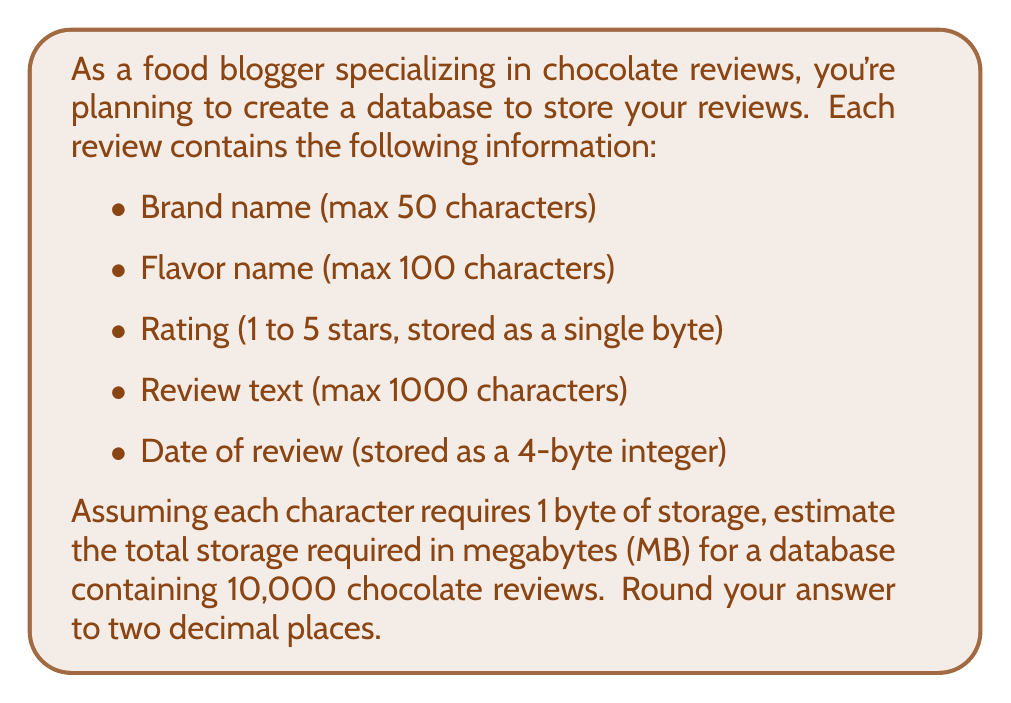Can you solve this math problem? Let's break down the storage requirements for each component of a review:

1. Brand name: 
   Max 50 characters = 50 bytes

2. Flavor name: 
   Max 100 characters = 100 bytes

3. Rating: 
   1 byte

4. Review text: 
   Max 1000 characters = 1000 bytes

5. Date of review: 
   4 bytes

Total storage per review:
$$50 + 100 + 1 + 1000 + 4 = 1155 \text{ bytes}$$

For 10,000 reviews:
$$10000 \times 1155 = 11550000 \text{ bytes}$$

To convert bytes to megabytes, we divide by $1024^2$ (since 1 MB = 1024 KB = 1024 * 1024 bytes):

$$\frac{11550000}{1024^2} \approx 11.0149 \text{ MB}$$

Rounding to two decimal places: 11.01 MB
Answer: 11.01 MB 